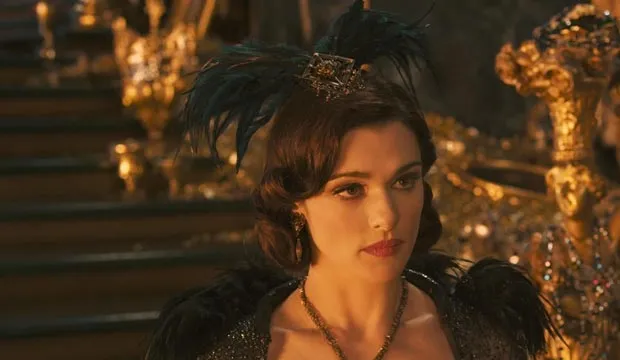If this were a painting in an art gallery, how would you interpret the artist's intention? In an art gallery, this painting could be interpreted as a powerful depiction of inner strength and authority. The artist may have intended to capture the essence of leadership and the heavy burden of responsibility that comes with it. The use of gold and black symbolizes both wealth and solemnity, suggesting that the character is torn between maintaining her power and grappling with the moral implications of her decisions. The feathered headpiece and elaborate setting further emphasize the blend of elegance and authority, inviting viewers to reflect on the dual nature of power—its allure and its weight. 